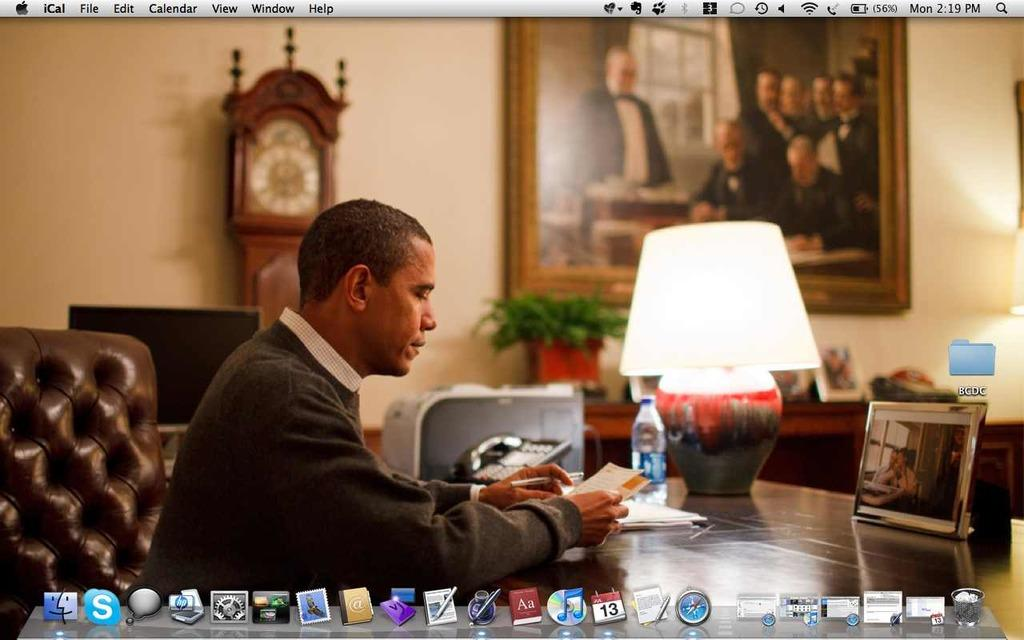What is the person in the image doing? The person is sitting on a chair in the image. Where is the person located in relation to the table? The person is around a table in the image. What objects can be seen on the table? There is a lamp, a water bottle, and a phone on the table in the image. What can be seen in the background of the image? There is a wall in the background of the image, with a photo frame and a clock visible. What type of plastic material is used to make the chair in the image? There is no mention of the chair being made of plastic in the image or the provided facts. 